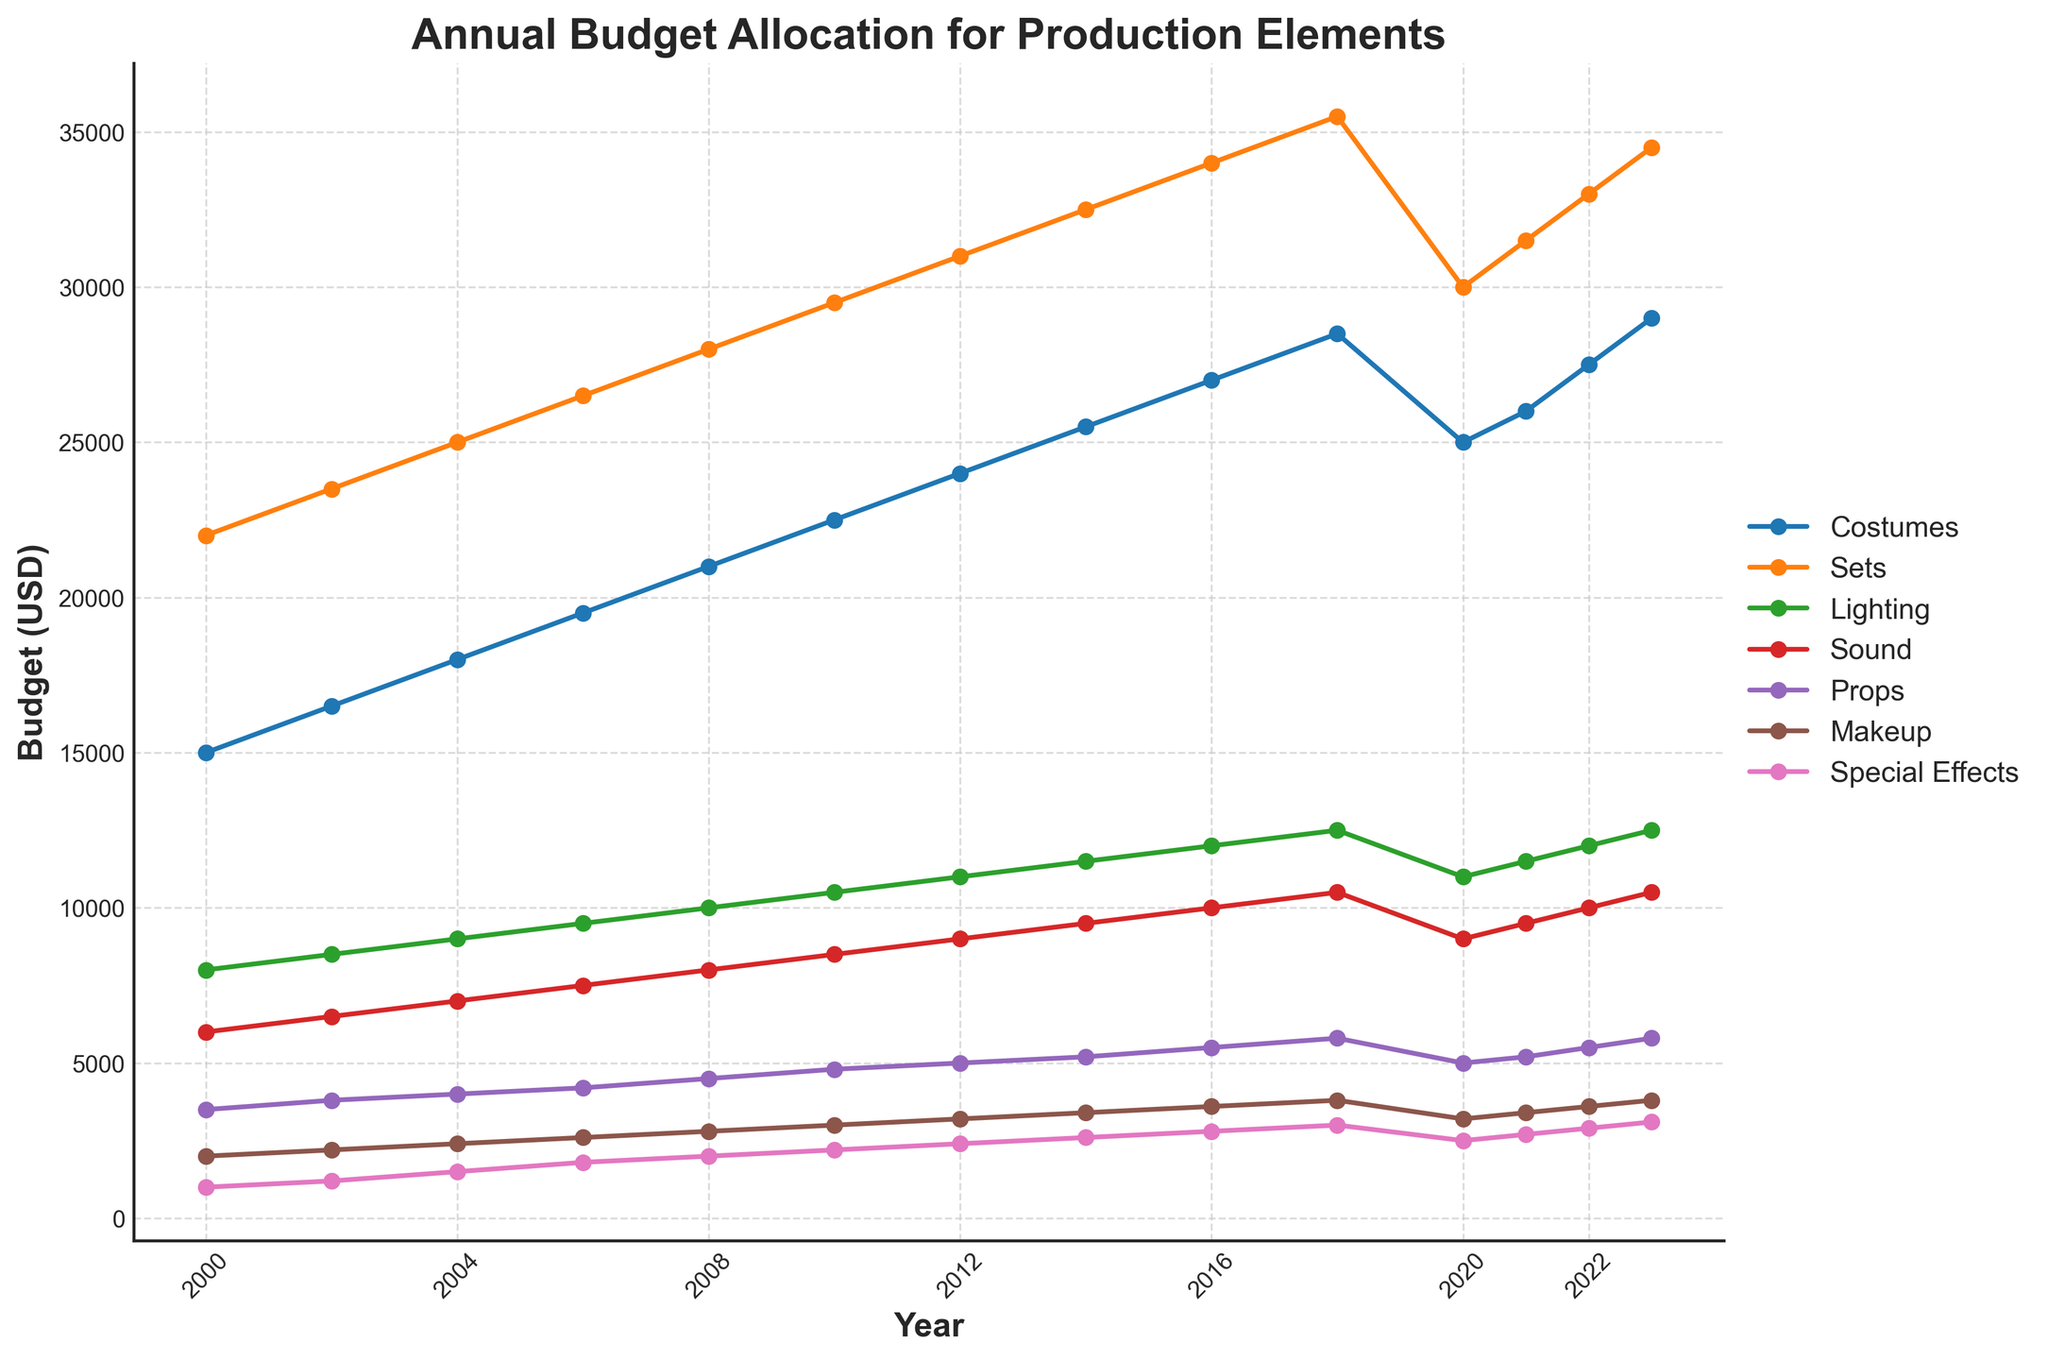What is the trend of the budget allocated for costumes from 2000 to 2023? From the line chart, observe the line representing costumes. Identify the start and end points and note their progression over time. The budget starts at $15,000 in 2000 and rises gradually to $29,000 in 2023.
Answer: Increasing trend Which production element had the highest budget increase from 2000 to 2023? Look at the difference in budget allocation for each element between 2000 and 2023. Sets increased from $22,000 to $34,500, which is an increase of $12,500. Compare this with other elements.
Answer: Sets Which year did the budget for lighting and sound both reach $10,500? Follow the lines for lighting and sound. Locate the intersection at the budget value of $10,500. This happens in the year 2018.
Answer: 2018 In 2020, which production element saw the most significant budget decrease compared to 2018? Compare the 2018 and 2020 budget values for all elements. Sets decreased from $35,500 in 2018 to $30,000 in 2020. Ensure no other element has a larger decrease.
Answer: Sets Calculate the average annual budget allocation for costumes over the entire period. Sum the budget values for costumes from 2000 to 2023 and divide by the number of years (14). The total sum is: $15,000 + $16,500 + $18,000 + $19,500 + $21,000 + $22,500 + $24,000 + $25,500 + $27,000 + $28,500 + $25,000 + $26,000 + $27,500 + $29,000 = $325,000. The average is $325,000/14.
Answer: $23,214.29 Which two production elements have budgets that never intersect over the years? Check each pair of production elements on their plotted lines to identify intersections. Costumes and special effects do not intersect at any point.
Answer: Costumes and Special Effects What was the approximate yearly budget growth for makeup from 2000 to 2023? Subtract the 2000 budget for makeup from the 2023 budget and then divide by the number of years. ($3,800 - $2,000) / 23 = $1,800 / 23.
Answer: $78.26 per year Which production element had the smallest budget in 2000, and did it ever surpass $5,000 by 2023? Identify the smallest budget in 2000 (Special Effects: $1,000). Check if the line for Special Effects crosses the $5,000 mark in later years. It does not surpass $5,000 by 2023.
Answer: Special Effects, No What is the combined budget for sets and lighting in 2014? Sum the budget values for sets and lighting in 2014. $32,500 (sets) + $11,500 (lighting) = $44,000.
Answer: $44,000 Are there any production elements whose budget increased consecutively every year without exception? Analyze the yearly progression of each element's budget. None have a straight consecutive increase every year due to variability, especially noting the changes in 2020.
Answer: No Which three production elements experienced a budget decrease in 2020, and what was the collective budget decrease amount? Identify elements with a decrease from 2018 to 2020: Costumes: $28,500 to $25,000 ($3,500 decrease), Sets: $35,500 to $30,000 ($5,500 decrease), Lighting: $12,500 to $11,000 ($1,500 decrease). The total decrease is $3,500 + $5,500 + $1,500.
Answer: Costumes, Sets, Lighting; $10,500 